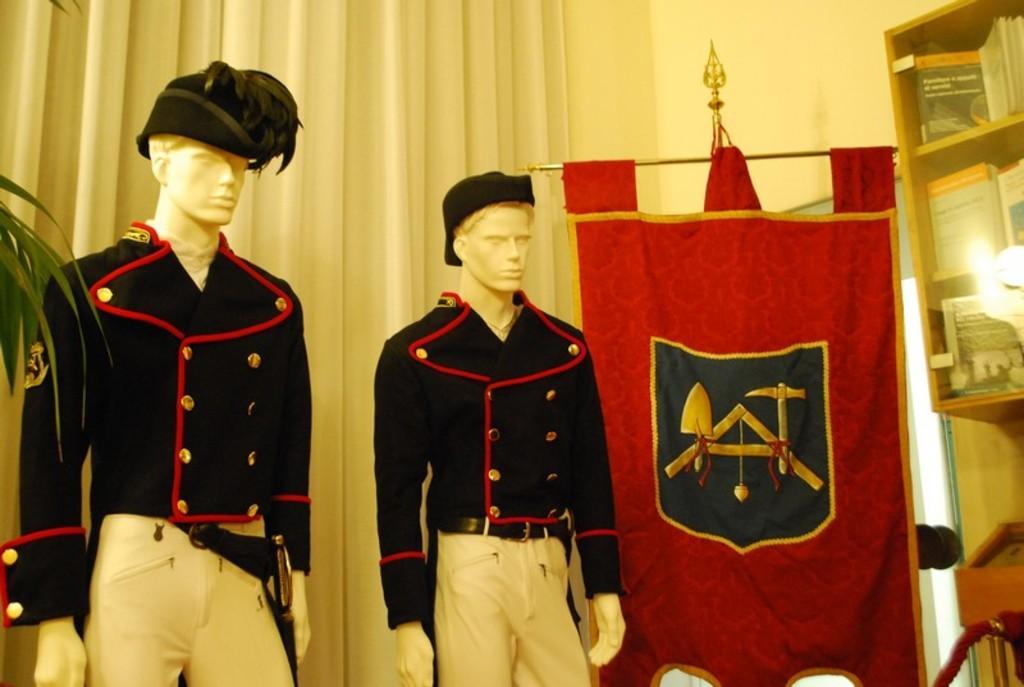Could you give a brief overview of what you see in this image? In this image, I can see two mannequins with the clothes and hats. It looks like a fabric banner, which is hanging. On the right side of the image, these are the books, which are kept in a book shelf. In the background, It looks like a curtain hanging, which is white in color. On the left side of the image, I can see the leaves. 